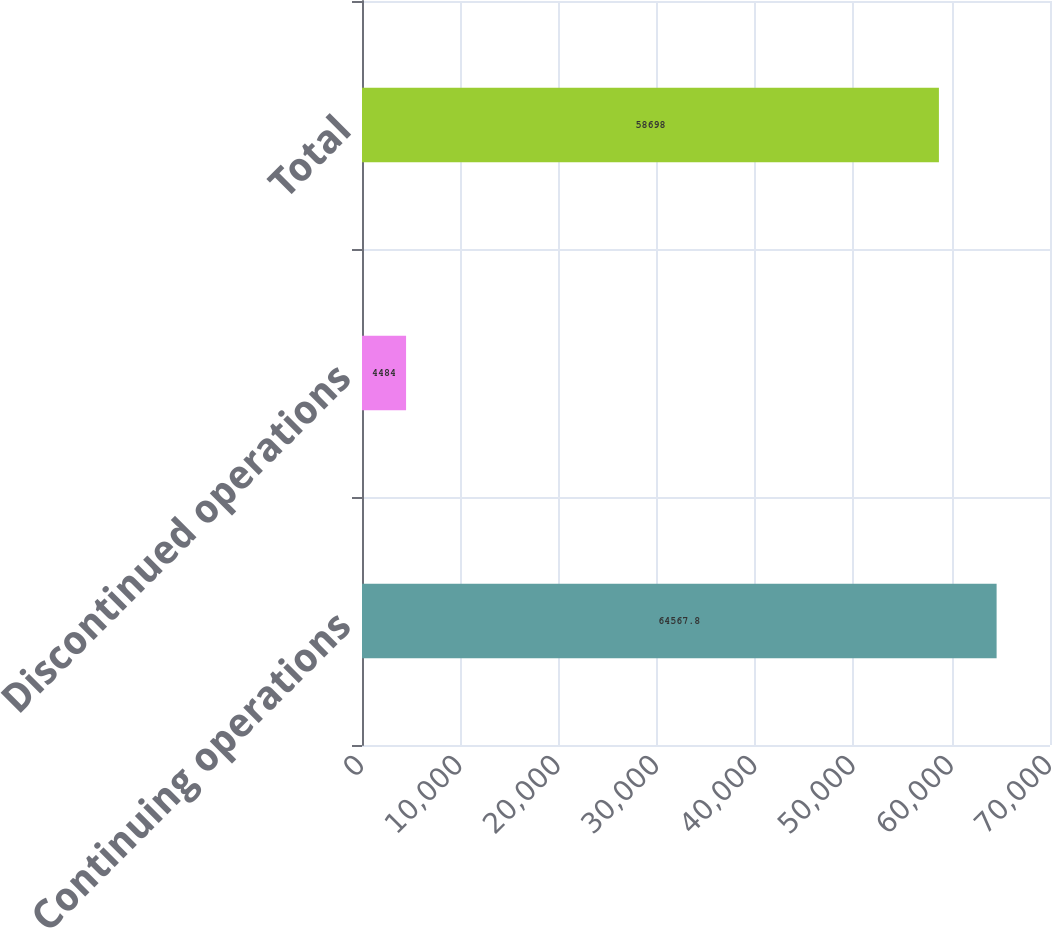Convert chart to OTSL. <chart><loc_0><loc_0><loc_500><loc_500><bar_chart><fcel>Continuing operations<fcel>Discontinued operations<fcel>Total<nl><fcel>64567.8<fcel>4484<fcel>58698<nl></chart> 